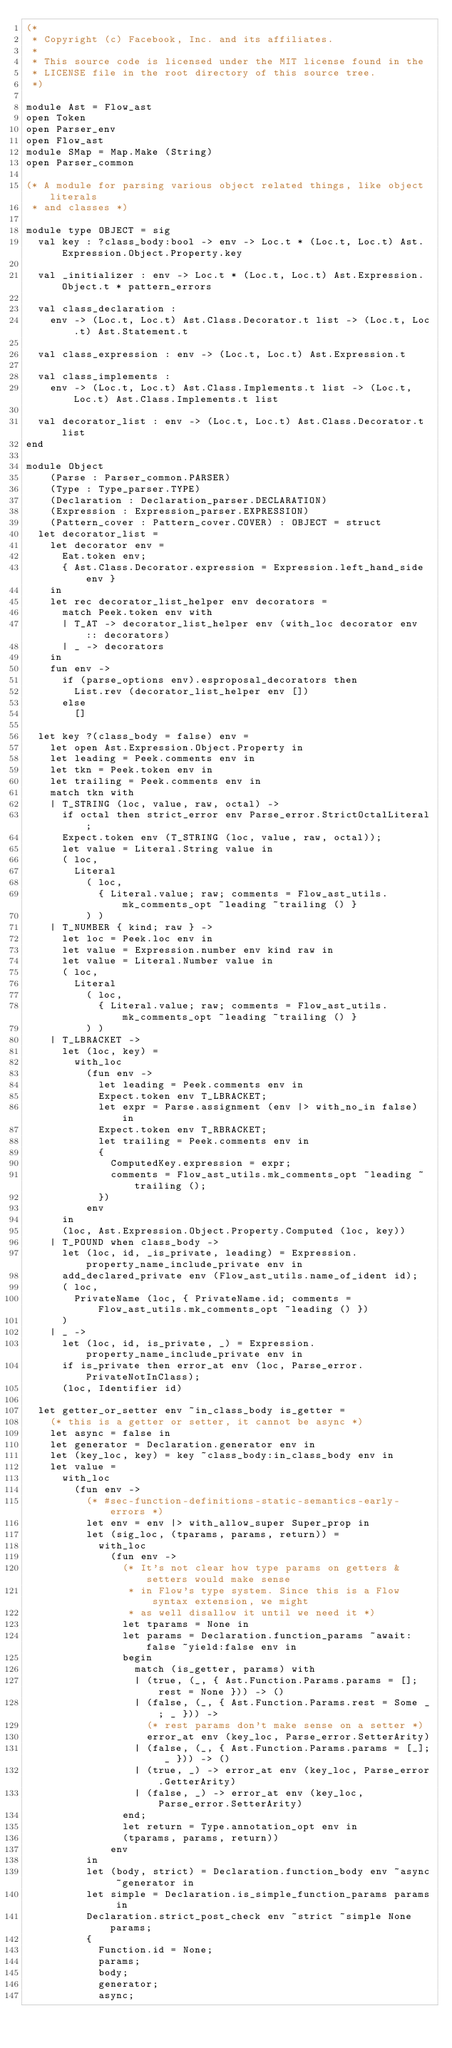Convert code to text. <code><loc_0><loc_0><loc_500><loc_500><_OCaml_>(*
 * Copyright (c) Facebook, Inc. and its affiliates.
 *
 * This source code is licensed under the MIT license found in the
 * LICENSE file in the root directory of this source tree.
 *)

module Ast = Flow_ast
open Token
open Parser_env
open Flow_ast
module SMap = Map.Make (String)
open Parser_common

(* A module for parsing various object related things, like object literals
 * and classes *)

module type OBJECT = sig
  val key : ?class_body:bool -> env -> Loc.t * (Loc.t, Loc.t) Ast.Expression.Object.Property.key

  val _initializer : env -> Loc.t * (Loc.t, Loc.t) Ast.Expression.Object.t * pattern_errors

  val class_declaration :
    env -> (Loc.t, Loc.t) Ast.Class.Decorator.t list -> (Loc.t, Loc.t) Ast.Statement.t

  val class_expression : env -> (Loc.t, Loc.t) Ast.Expression.t

  val class_implements :
    env -> (Loc.t, Loc.t) Ast.Class.Implements.t list -> (Loc.t, Loc.t) Ast.Class.Implements.t list

  val decorator_list : env -> (Loc.t, Loc.t) Ast.Class.Decorator.t list
end

module Object
    (Parse : Parser_common.PARSER)
    (Type : Type_parser.TYPE)
    (Declaration : Declaration_parser.DECLARATION)
    (Expression : Expression_parser.EXPRESSION)
    (Pattern_cover : Pattern_cover.COVER) : OBJECT = struct
  let decorator_list =
    let decorator env =
      Eat.token env;
      { Ast.Class.Decorator.expression = Expression.left_hand_side env }
    in
    let rec decorator_list_helper env decorators =
      match Peek.token env with
      | T_AT -> decorator_list_helper env (with_loc decorator env :: decorators)
      | _ -> decorators
    in
    fun env ->
      if (parse_options env).esproposal_decorators then
        List.rev (decorator_list_helper env [])
      else
        []

  let key ?(class_body = false) env =
    let open Ast.Expression.Object.Property in
    let leading = Peek.comments env in
    let tkn = Peek.token env in
    let trailing = Peek.comments env in
    match tkn with
    | T_STRING (loc, value, raw, octal) ->
      if octal then strict_error env Parse_error.StrictOctalLiteral;
      Expect.token env (T_STRING (loc, value, raw, octal));
      let value = Literal.String value in
      ( loc,
        Literal
          ( loc,
            { Literal.value; raw; comments = Flow_ast_utils.mk_comments_opt ~leading ~trailing () }
          ) )
    | T_NUMBER { kind; raw } ->
      let loc = Peek.loc env in
      let value = Expression.number env kind raw in
      let value = Literal.Number value in
      ( loc,
        Literal
          ( loc,
            { Literal.value; raw; comments = Flow_ast_utils.mk_comments_opt ~leading ~trailing () }
          ) )
    | T_LBRACKET ->
      let (loc, key) =
        with_loc
          (fun env ->
            let leading = Peek.comments env in
            Expect.token env T_LBRACKET;
            let expr = Parse.assignment (env |> with_no_in false) in
            Expect.token env T_RBRACKET;
            let trailing = Peek.comments env in
            {
              ComputedKey.expression = expr;
              comments = Flow_ast_utils.mk_comments_opt ~leading ~trailing ();
            })
          env
      in
      (loc, Ast.Expression.Object.Property.Computed (loc, key))
    | T_POUND when class_body ->
      let (loc, id, _is_private, leading) = Expression.property_name_include_private env in
      add_declared_private env (Flow_ast_utils.name_of_ident id);
      ( loc,
        PrivateName (loc, { PrivateName.id; comments = Flow_ast_utils.mk_comments_opt ~leading () })
      )
    | _ ->
      let (loc, id, is_private, _) = Expression.property_name_include_private env in
      if is_private then error_at env (loc, Parse_error.PrivateNotInClass);
      (loc, Identifier id)

  let getter_or_setter env ~in_class_body is_getter =
    (* this is a getter or setter, it cannot be async *)
    let async = false in
    let generator = Declaration.generator env in
    let (key_loc, key) = key ~class_body:in_class_body env in
    let value =
      with_loc
        (fun env ->
          (* #sec-function-definitions-static-semantics-early-errors *)
          let env = env |> with_allow_super Super_prop in
          let (sig_loc, (tparams, params, return)) =
            with_loc
              (fun env ->
                (* It's not clear how type params on getters & setters would make sense
                 * in Flow's type system. Since this is a Flow syntax extension, we might
                 * as well disallow it until we need it *)
                let tparams = None in
                let params = Declaration.function_params ~await:false ~yield:false env in
                begin
                  match (is_getter, params) with
                  | (true, (_, { Ast.Function.Params.params = []; rest = None })) -> ()
                  | (false, (_, { Ast.Function.Params.rest = Some _; _ })) ->
                    (* rest params don't make sense on a setter *)
                    error_at env (key_loc, Parse_error.SetterArity)
                  | (false, (_, { Ast.Function.Params.params = [_]; _ })) -> ()
                  | (true, _) -> error_at env (key_loc, Parse_error.GetterArity)
                  | (false, _) -> error_at env (key_loc, Parse_error.SetterArity)
                end;
                let return = Type.annotation_opt env in
                (tparams, params, return))
              env
          in
          let (body, strict) = Declaration.function_body env ~async ~generator in
          let simple = Declaration.is_simple_function_params params in
          Declaration.strict_post_check env ~strict ~simple None params;
          {
            Function.id = None;
            params;
            body;
            generator;
            async;</code> 